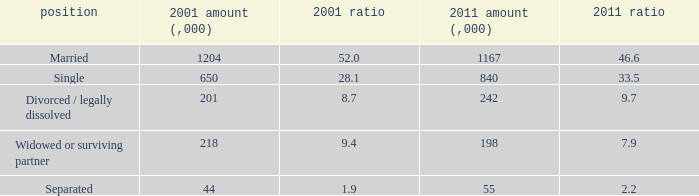What is the lowest 2011 number (,000)? 55.0. 